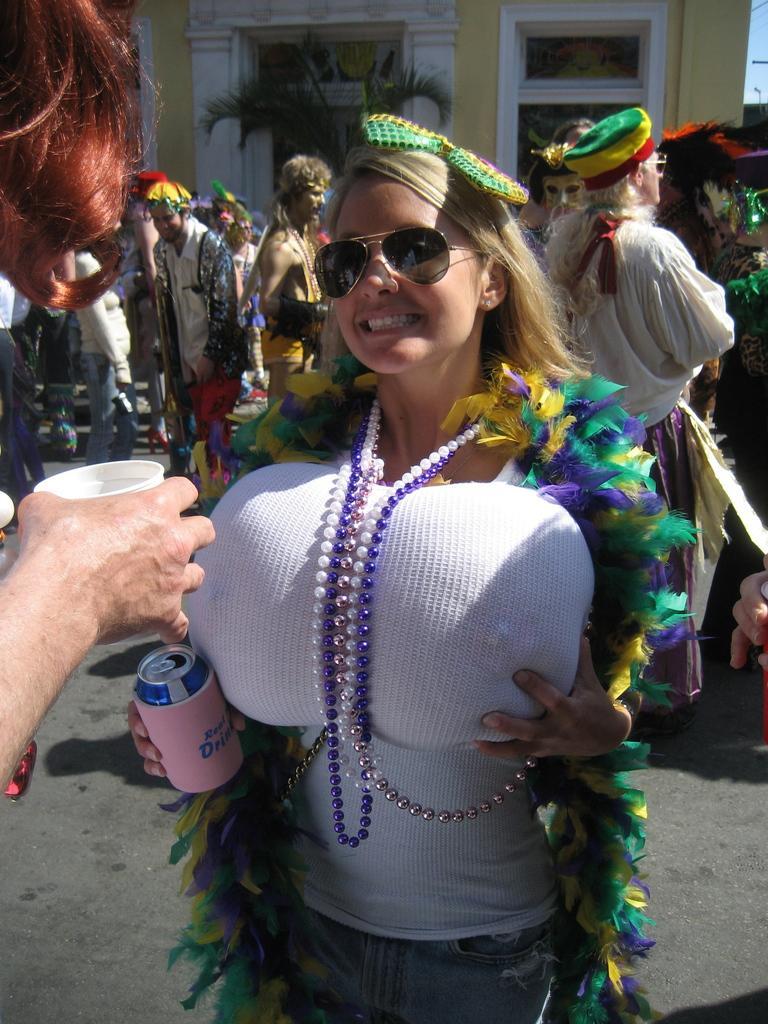Please provide a concise description of this image. In this picture there is a woman standing and smiling and there is a person holding the cup. At the back there are group of people with costumes are standing and there is a building and tree. At the top there is sky. At the bottom there is a road. 